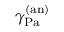Convert formula to latex. <formula><loc_0><loc_0><loc_500><loc_500>\gamma _ { P a } ^ { ( a n ) }</formula> 